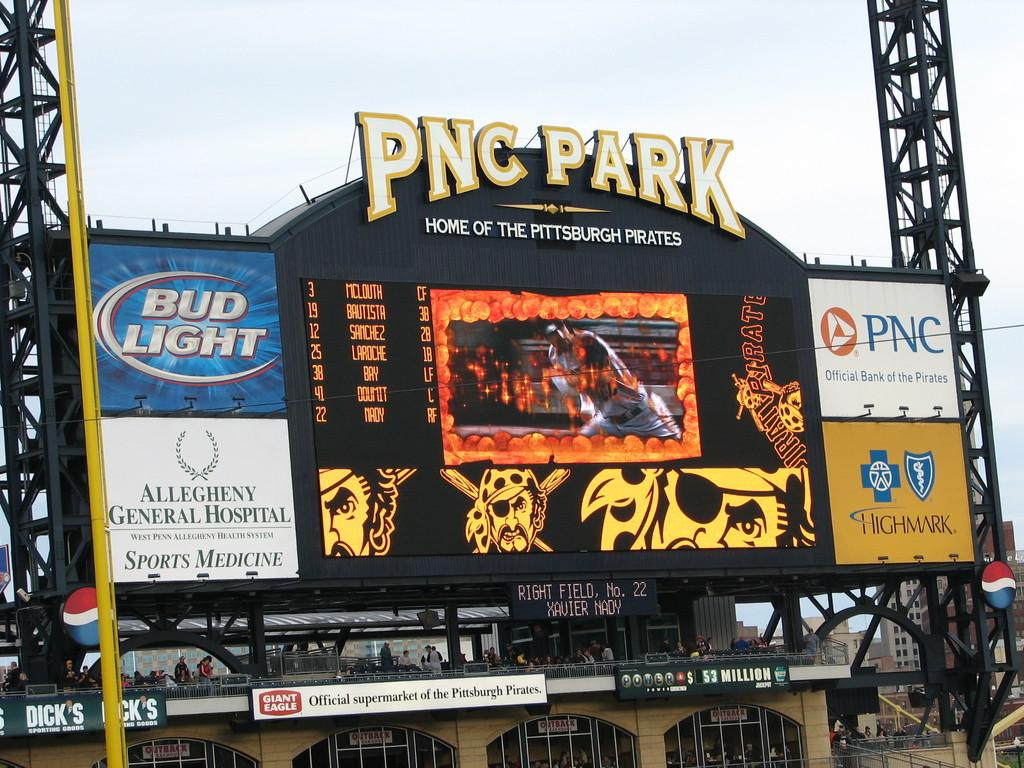<image>
Summarize the visual content of the image. The PNC Park scoreboard shows baseball highlights and a series of ads for products like Bud Light. 